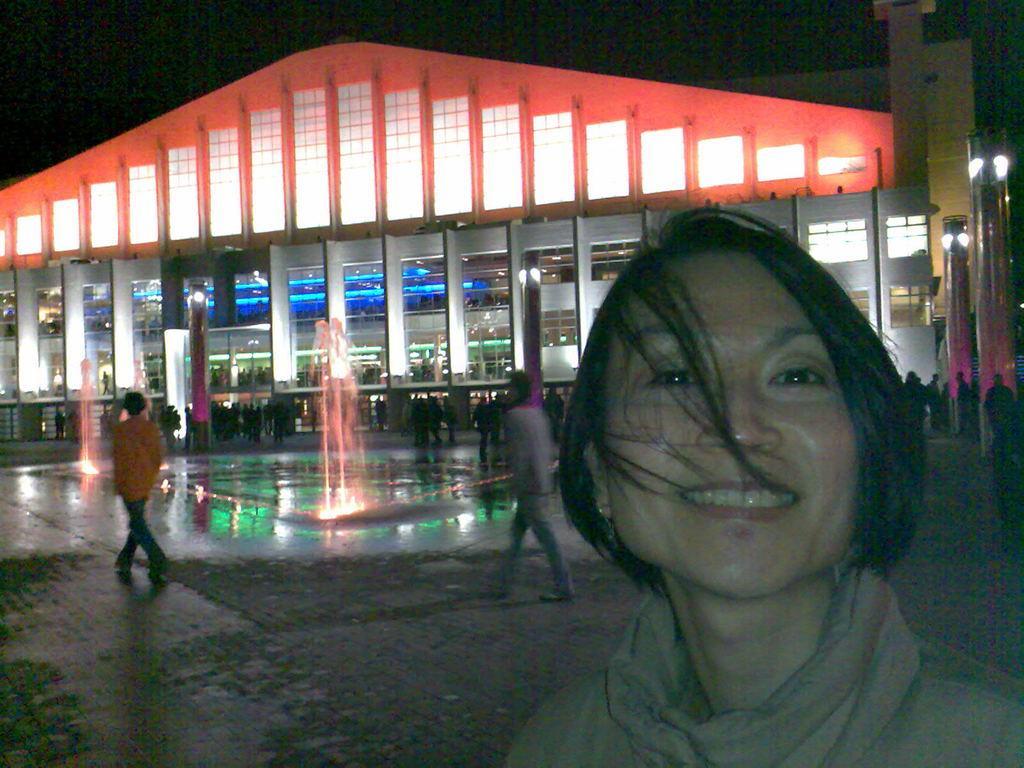Could you give a brief overview of what you see in this image? In this picture I can see a woman smiling, and in the background there are group of people, there are lights, water fountains and a building. 